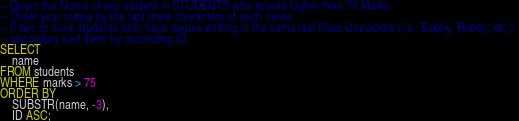<code> <loc_0><loc_0><loc_500><loc_500><_SQL_>-- Query the Name of any student in STUDENTS who scored higher than 75 Marks.
-- Order your output by the last three characters of each name. 
-- If two or more students both have names ending in the same last three characters (i.e.: Bobby, Robby, etc.), 
-- secondary sort them by ascending ID.
SELECT 
    name 
FROM students
WHERE marks > 75
ORDER BY 
    SUBSTR(name, -3), 
    ID ASC;</code> 